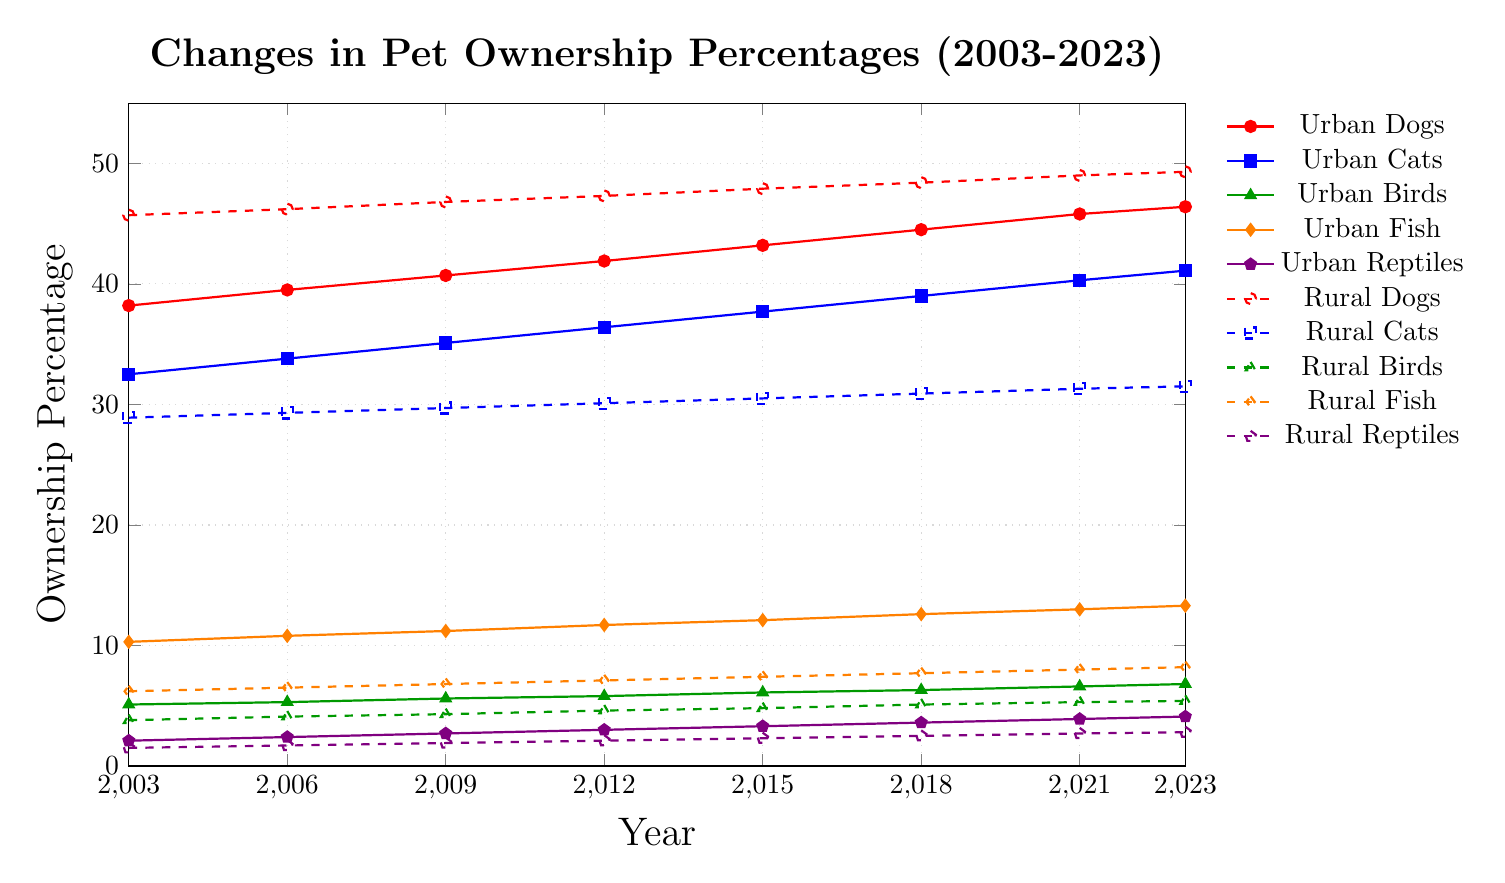Which species saw the highest increase in ownership percentage in urban areas from 2003 to 2023? To find the species with the highest increase in ownership percentage in urban areas, subtract the 2003 value from the 2023 value for each species: Dogs (46.4 - 38.2 = 8.2), Cats (41.1 - 32.5 = 8.6), Birds (6.8 - 5.1 = 1.7), Fish (13.3 - 10.3 = 3.0), Reptiles (4.1 - 2.1 = 2.0). The highest increase is for Urban Cats, which increased by 8.6.
Answer: Urban Cats What is the difference in ownership percentage between rural dogs and urban dogs in 2023? To find the difference between rural dogs and urban dogs in 2023, subtract the urban dogs' percentage from the rural dogs' percentage: 49.3 (rural dogs) - 46.4 (urban dogs) = 2.9.
Answer: 2.9 From 2003 to 2023, did the ownership percentage of urban birds ever surpass that of rural birds? Compare the ownership percentages of urban and rural birds for each year. In 2003 (urban: 5.1, rural: 3.8), 2006 (urban: 5.3, rural: 4.1), 2009 (urban: 5.6, rural: 4.3), 2012 (urban: 5.8, rural: 4.6), 2015 (urban: 6.1, rural: 4.8), 2018 (urban: 6.3, rural: 5.1), 2021 (urban: 6.6, rural: 5.3), and 2023 (urban: 6.8, rural: 5.4), urban bird ownership percentages are higher than rural bird ownership percentages in every year.
Answer: Yes Which year had the smallest difference between urban and rural fish ownership percentages? Calculate the difference between urban and rural fish ownership percentages for each year: 2003 (10.3 - 6.2 = 4.1), 2006 (10.8 - 6.5 = 4.3), 2009 (11.2 - 6.8 = 4.4), 2012 (11.7 - 7.1 = 4.6), 2015 (12.1 - 7.4 = 4.7), 2018 (12.6 - 7.7 = 4.9), 2021 (13.0 - 8.0 = 5.0), 2023 (13.3 - 8.2 = 5.1). The smallest difference is 4.1, which occurs in 2003.
Answer: 2003 What was the average ownership percentage of urban cats over the 20-year period? Add the ownership percentages for urban cats across all years and divide by the number of data points: (32.5 + 33.8 + 35.1 + 36.4 + 37.7 + 39.0 + 40.3 + 41.1) / 8. Sum = 296.9, so the average = 296.9 / 8 = 37.11.
Answer: 37.11 Which species in rural areas showed the slowest increase in ownership percentage from 2003 to 2023? Calculate the increase in ownership percentage for each species in rural areas: Dogs (49.3 - 45.7 = 3.6), Cats (31.5 - 28.9 = 2.6), Birds (5.4 - 3.8 = 1.6), Fish (8.2 - 6.2 = 2.0), Reptiles (2.8 - 1.5 = 1.3). The slowest increase is for Rural Reptiles with an increase of 1.3.
Answer: Rural Reptiles In what year did urban reptiles ownership percentage cross the 3% mark for the first time? Examine the ownership percentages for urban reptiles: 2003 (2.1), 2006 (2.4), 2009 (2.7), 2012 (3.0), 2015 (3.3), 2018 (3.6), 2021 (3.9), and 2023 (4.1). The first year it crosses 3% is 2012.
Answer: 2012 